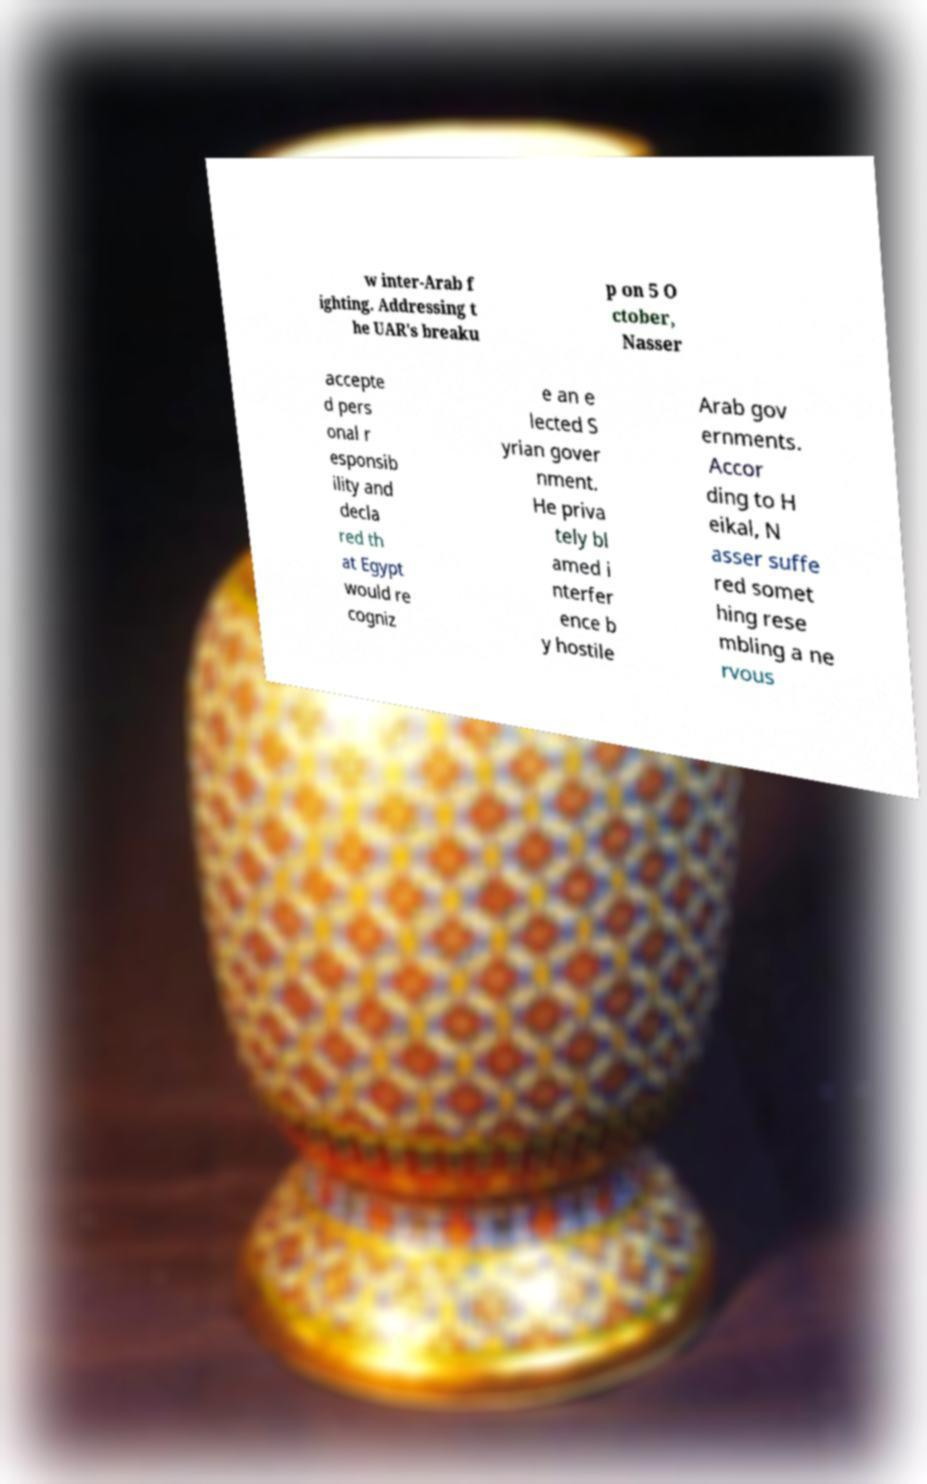Could you assist in decoding the text presented in this image and type it out clearly? w inter-Arab f ighting. Addressing t he UAR's breaku p on 5 O ctober, Nasser accepte d pers onal r esponsib ility and decla red th at Egypt would re cogniz e an e lected S yrian gover nment. He priva tely bl amed i nterfer ence b y hostile Arab gov ernments. Accor ding to H eikal, N asser suffe red somet hing rese mbling a ne rvous 